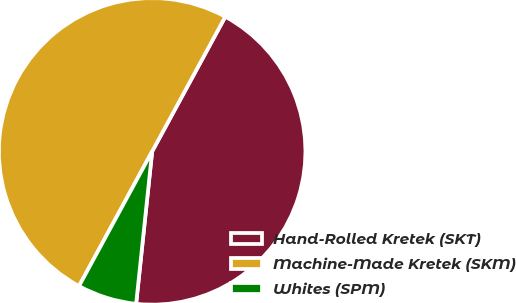<chart> <loc_0><loc_0><loc_500><loc_500><pie_chart><fcel>Hand-Rolled Kretek (SKT)<fcel>Machine-Made Kretek (SKM)<fcel>Whites (SPM)<nl><fcel>43.75%<fcel>50.0%<fcel>6.25%<nl></chart> 